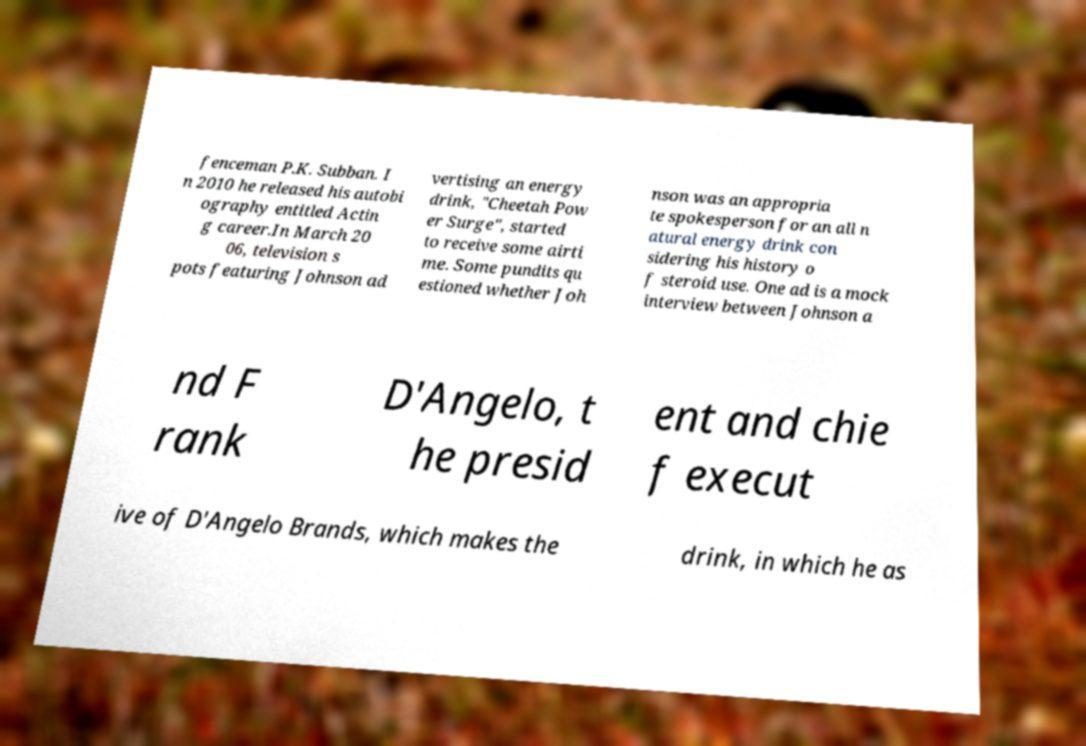What messages or text are displayed in this image? I need them in a readable, typed format. fenceman P.K. Subban. I n 2010 he released his autobi ography entitled Actin g career.In March 20 06, television s pots featuring Johnson ad vertising an energy drink, "Cheetah Pow er Surge", started to receive some airti me. Some pundits qu estioned whether Joh nson was an appropria te spokesperson for an all n atural energy drink con sidering his history o f steroid use. One ad is a mock interview between Johnson a nd F rank D'Angelo, t he presid ent and chie f execut ive of D'Angelo Brands, which makes the drink, in which he as 